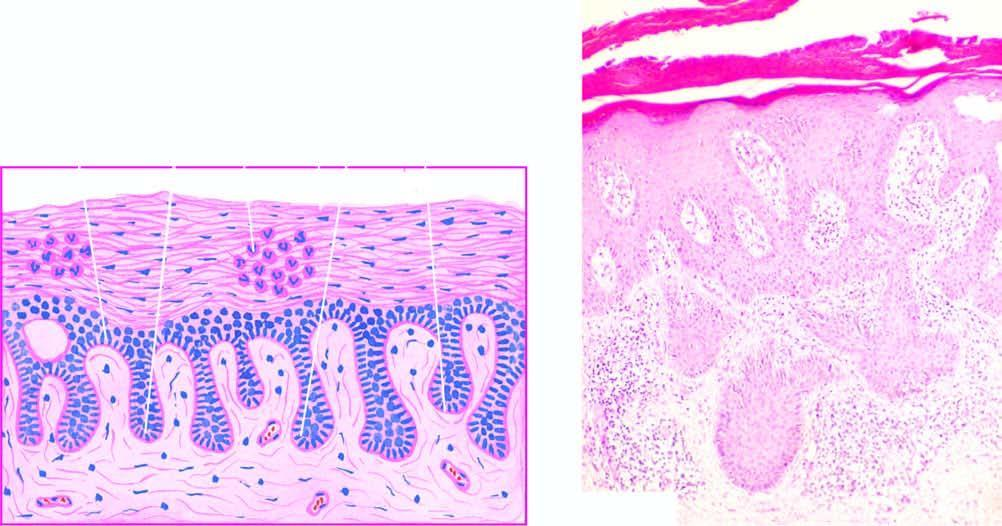s the anorectal margin marked parakeratosis with diagnostic munro microabscesses in the parakeratotic layer?
Answer the question using a single word or phrase. No 